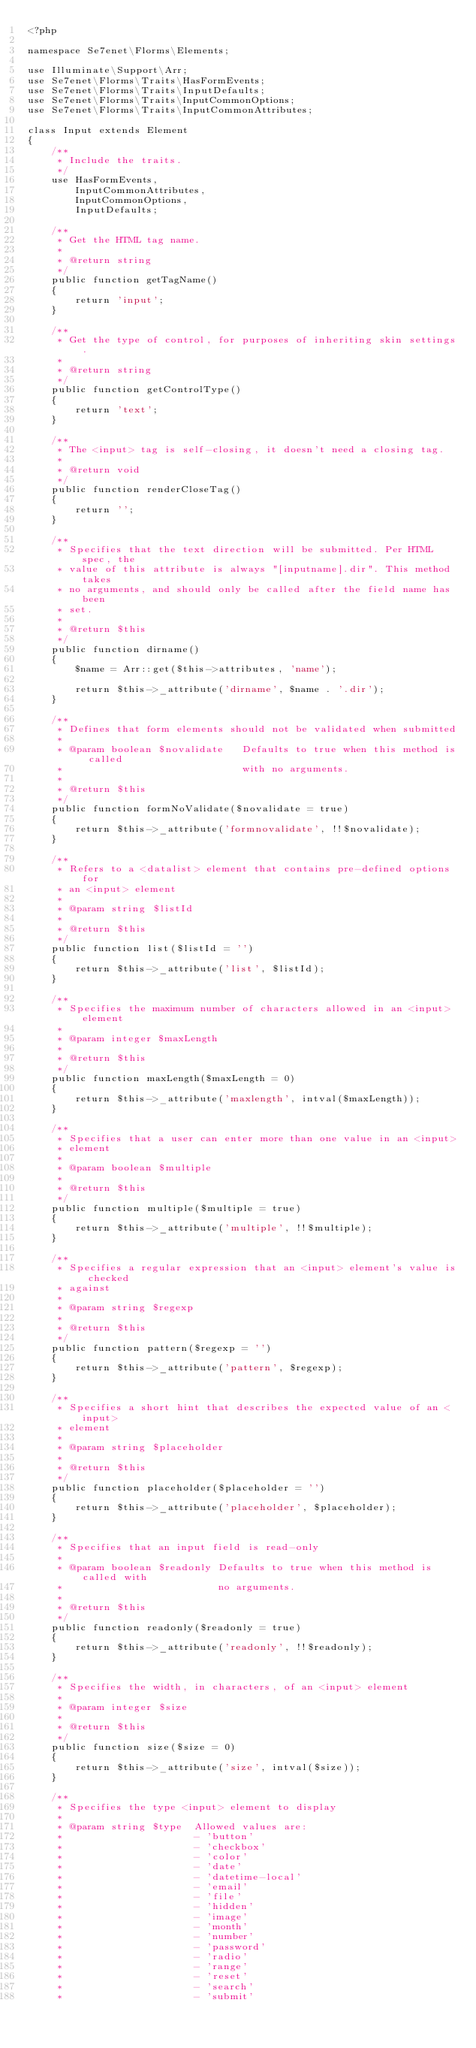<code> <loc_0><loc_0><loc_500><loc_500><_PHP_><?php

namespace Se7enet\Florms\Elements;

use Illuminate\Support\Arr;
use Se7enet\Florms\Traits\HasFormEvents;
use Se7enet\Florms\Traits\InputDefaults;
use Se7enet\Florms\Traits\InputCommonOptions;
use Se7enet\Florms\Traits\InputCommonAttributes;

class Input extends Element
{
    /**
     * Include the traits.
     */
    use HasFormEvents,
        InputCommonAttributes,
        InputCommonOptions,
        InputDefaults;

    /**
     * Get the HTML tag name.
     *
     * @return string
     */
    public function getTagName()
    {
        return 'input';
    }

    /**
     * Get the type of control, for purposes of inheriting skin settings.
     *
     * @return string
     */
    public function getControlType()
    {
        return 'text';
    }

    /**
     * The <input> tag is self-closing, it doesn't need a closing tag.
     *
     * @return void
     */
    public function renderCloseTag()
    {
        return '';
    }

    /**
     * Specifies that the text direction will be submitted. Per HTML spec, the
     * value of this attribute is always "[inputname].dir". This method takes
     * no arguments, and should only be called after the field name has been
     * set.
     *
     * @return $this
     */
    public function dirname()
    {
        $name = Arr::get($this->attributes, 'name');

        return $this->_attribute('dirname', $name . '.dir');
    }

    /**
     * Defines that form elements should not be validated when submitted
     *
     * @param boolean $novalidate   Defaults to true when this method is called
     *                              with no arguments.
     *
     * @return $this
     */
    public function formNoValidate($novalidate = true)
    {
        return $this->_attribute('formnovalidate', !!$novalidate);
    }

    /**
     * Refers to a <datalist> element that contains pre-defined options for
     * an <input> element
     *
     * @param string $listId
     *
     * @return $this
     */
    public function list($listId = '')
    {
        return $this->_attribute('list', $listId);
    }

    /**
     * Specifies the maximum number of characters allowed in an <input> element
     *
     * @param integer $maxLength
     *
     * @return $this
     */
    public function maxLength($maxLength = 0)
    {
        return $this->_attribute('maxlength', intval($maxLength));
    }

    /**
     * Specifies that a user can enter more than one value in an <input>
     * element
     *
     * @param boolean $multiple
     *
     * @return $this
     */
    public function multiple($multiple = true)
    {
        return $this->_attribute('multiple', !!$multiple);
    }

    /**
     * Specifies a regular expression that an <input> element's value is checked
     * against
     *
     * @param string $regexp
     *
     * @return $this
     */
    public function pattern($regexp = '')
    {
        return $this->_attribute('pattern', $regexp);
    }

    /**
     * Specifies a short hint that describes the expected value of an <input>
     * element
     *
     * @param string $placeholder
     *
     * @return $this
     */
    public function placeholder($placeholder = '')
    {
        return $this->_attribute('placeholder', $placeholder);
    }

    /**
     * Specifies that an input field is read-only
     *
     * @param boolean $readonly Defaults to true when this method is called with
     *                          no arguments.
     *
     * @return $this
     */
    public function readonly($readonly = true)
    {
        return $this->_attribute('readonly', !!$readonly);
    }

    /**
     * Specifies the width, in characters, of an <input> element
     *
     * @param integer $size
     *
     * @return $this
     */
    public function size($size = 0)
    {
        return $this->_attribute('size', intval($size));
    }

    /**
     * Specifies the type <input> element to display
     *
     * @param string $type  Allowed values are:
     *                      - 'button'
     *                      - 'checkbox'
     *                      - 'color'
     *                      - 'date'
     *                      - 'datetime-local'
     *                      - 'email'
     *                      - 'file'
     *                      - 'hidden'
     *                      - 'image'
     *                      - 'month'
     *                      - 'number'
     *                      - 'password'
     *                      - 'radio'
     *                      - 'range'
     *                      - 'reset'
     *                      - 'search'
     *                      - 'submit'</code> 